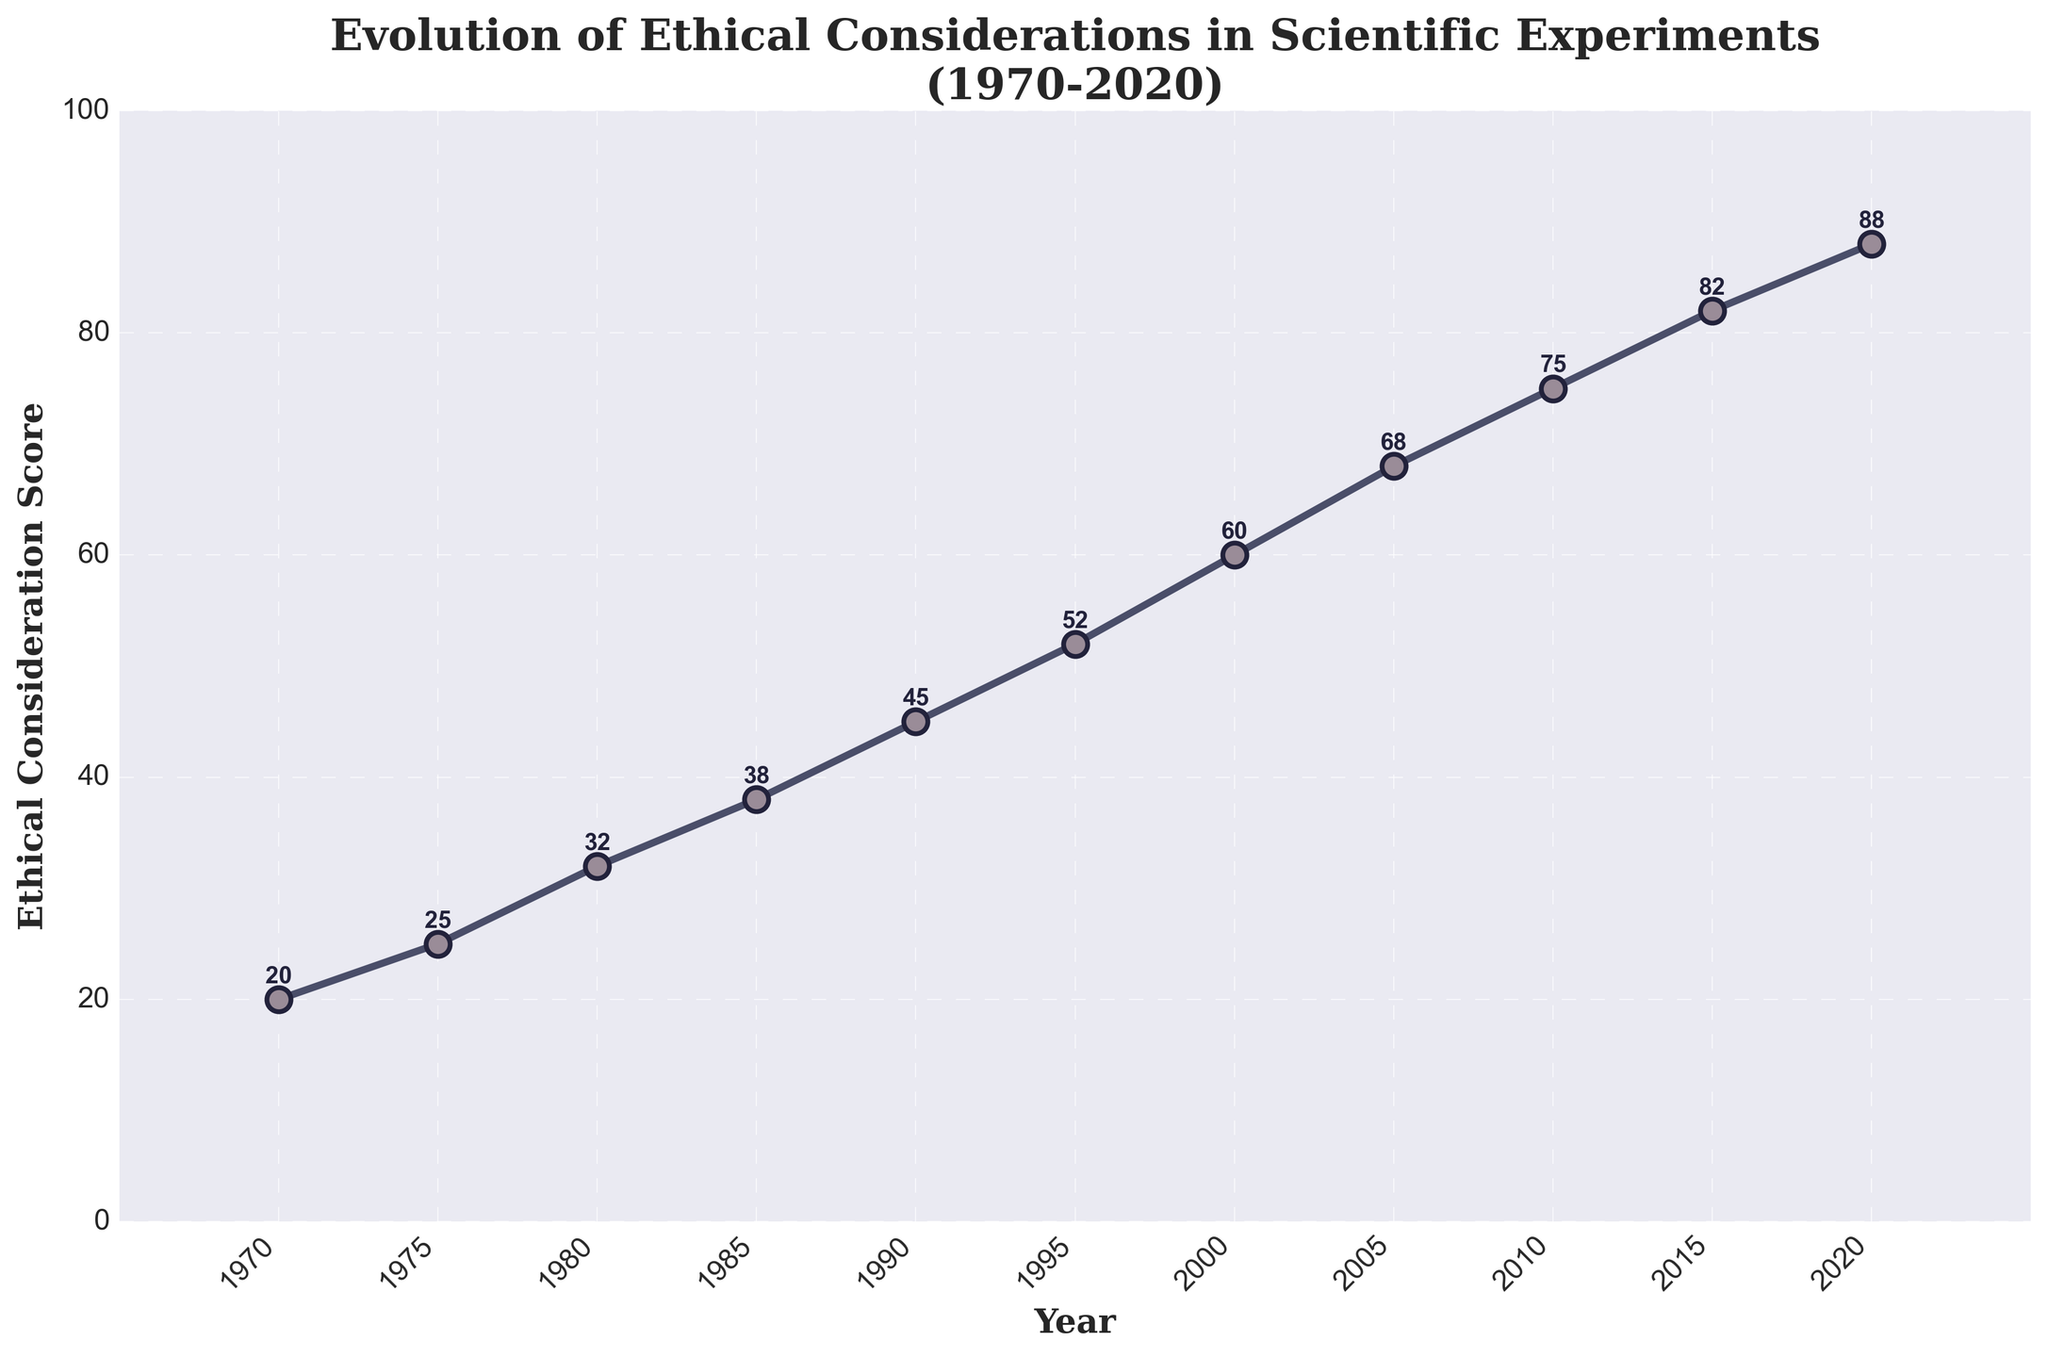What is the Ethical Consideration Score in the year 1990? Look for the point on the line chart corresponding to the year 1990 and identify the score marked at that point.
Answer: 45 Between which years did the Ethical Consideration Score increase the most? By observing the slopes and scores at different year intervals, the steepest increase appears between 1975 and 1980. Calculate delta: 32 (1980) - 25 (1975) = 7.
Answer: 1975-1980 What is the average Ethical Consideration Score from 1980 to 2000? Collect the scores for years 1980, 1985, 1990, 1995, and 2000, which are 32, 38, 45, 52, and 60, respectively. Add them: 32+38+45+52+60=227. Then divide by the number of data points: 227/5.
Answer: 45.4 By how much did the Ethical Consideration Score increase from 2000 to 2020? Find the scores for 2000 (60) and 2020 (88). Subtract the former from the latter: 88 - 60 = 28.
Answer: 28 Which year had the smallest increase in Ethical Consideration Score compared to its previous interval? Find the difference between consecutive scores and the smallest difference appears between 1980 (32) and 1975 (25) with a difference of 7.
Answer: 1975-1980 In which decade did the Ethical Consideration Score see a consistent linear increase? Observing the chart, the increase appears linear from 1990 to 2000. The scores consistently rise each period.
Answer: 1990-2000 How does the Ethical Consideration Score in 2010 compare to 1995? The score in 2010 (75) is higher than in 1995 (52). The difference can be calculated: 75 - 52 = 23.
Answer: Higher by 23 What is the median Ethical Consideration Score from 1970 to 2020? Arrange the scores: 20, 25, 32, 38, 45, 52, 60, 68, 75, 82, 88. The median is the middle value in an ordered list, which is the 6th value: 52 (1995).
Answer: 52 By how much did the score change in the first and last five-year periods? Calculate changes: 1970-1975 (25-20=5), 2015-2020 (88-82=6). The first period’s change is 5, and the last period’s change is 6.
Answer: Increased by 1 more in the last period What features visually distinguish the markers on the line chart? The markers on the line chart are circles, colored differently with a filled center and bordered edges.
Answer: Circles, filled center, bordered edges 